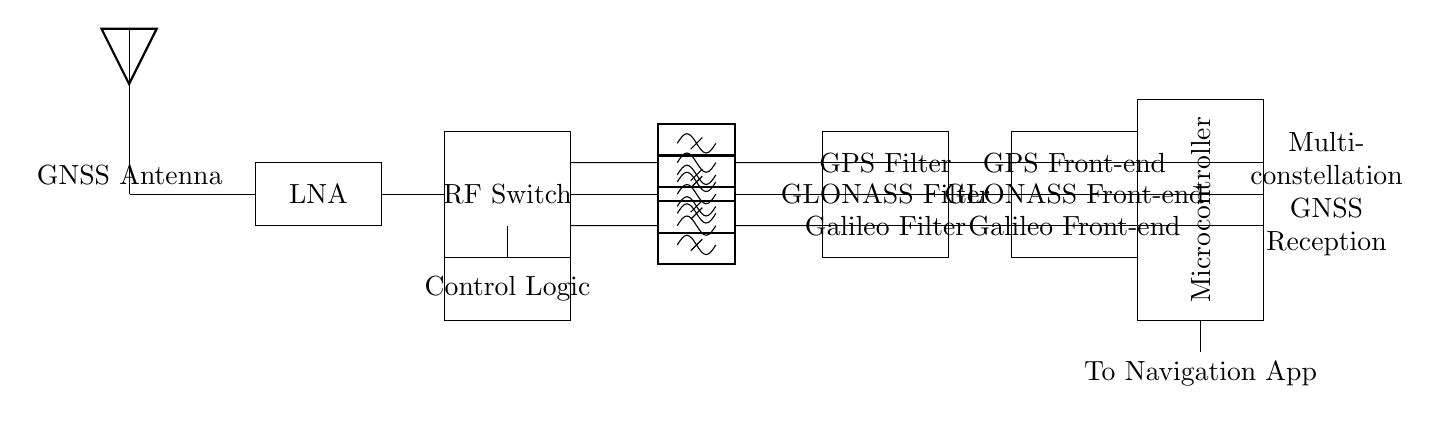What is the function of the Low Noise Amplifier? The Low Noise Amplifier (LNA) amplifies weak signals received from the GNSS antenna before further processing, ensuring that the signal strength is adequate for filtering and demodulation.
Answer: Amplification of weak signals What components are involved in the GPS signal path? The GPS signal path includes the RF Switch, a bandpass filter, a GPS Filter, and a GPS Front-end, each serving a crucial role in filtering and processing the incoming GPS signals.
Answer: RF Switch, Bandpass Filter, GPS Filter, GPS Front-end What could the Control Logic be used for? The Control Logic is responsible for switching between different GNSS paths, determining which satellite system to prioritize based on various operational conditions or user settings.
Answer: Switching between GNSS paths How many multi-constellation GNSS systems are processed in this circuit? The circuit is set up to process three multi-constellation GNSS systems: GPS, GLONASS, and Galileo, allowing for enhanced navigation capabilities.
Answer: Three What does the Microcontroller do in this circuit? The Microcontroller processes the filtered GNSS signals, making decisions based on the logic provided and sending data to the navigation application.
Answer: Processing filtered GNSS signals Which component acts as a filter specifically for the GLONASS signal? The GLONASS Filter is specifically designed to filter the signals from the GLONASS system, ensuring that only relevant frequencies are passed through for further processing.
Answer: GLONASS Filter 